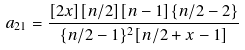Convert formula to latex. <formula><loc_0><loc_0><loc_500><loc_500>a _ { 2 1 } = \frac { [ 2 x ] [ n / 2 ] [ n - 1 ] \{ n / 2 - 2 \} } { \{ n / 2 - 1 \} ^ { 2 } [ n / 2 + x - 1 ] }</formula> 